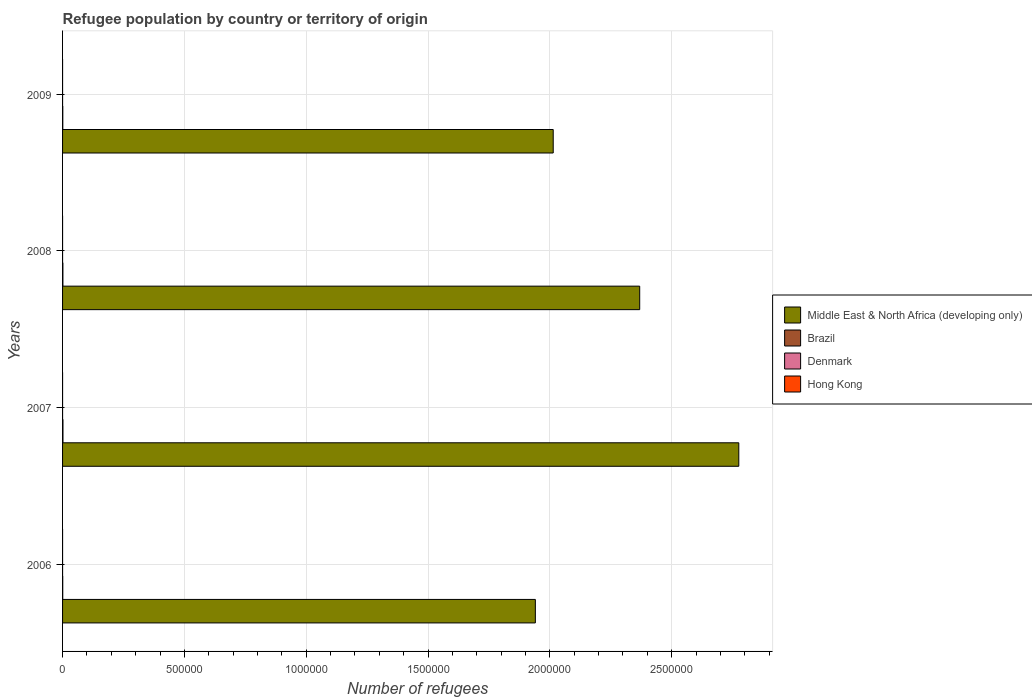How many different coloured bars are there?
Your response must be concise. 4. Are the number of bars on each tick of the Y-axis equal?
Make the answer very short. Yes. How many bars are there on the 3rd tick from the top?
Provide a succinct answer. 4. How many bars are there on the 4th tick from the bottom?
Offer a very short reply. 4. What is the label of the 2nd group of bars from the top?
Keep it short and to the point. 2008. In how many cases, is the number of bars for a given year not equal to the number of legend labels?
Your answer should be very brief. 0. What is the number of refugees in Brazil in 2006?
Provide a succinct answer. 707. Across all years, what is the maximum number of refugees in Brazil?
Your response must be concise. 1624. Across all years, what is the minimum number of refugees in Brazil?
Your answer should be compact. 707. In which year was the number of refugees in Hong Kong maximum?
Your response must be concise. 2009. In which year was the number of refugees in Hong Kong minimum?
Your answer should be very brief. 2006. What is the total number of refugees in Denmark in the graph?
Provide a succinct answer. 47. What is the difference between the number of refugees in Denmark in 2006 and that in 2008?
Offer a very short reply. 1. What is the difference between the number of refugees in Hong Kong in 2009 and the number of refugees in Denmark in 2008?
Your response must be concise. 1. What is the average number of refugees in Hong Kong per year?
Give a very brief answer. 11. In the year 2006, what is the difference between the number of refugees in Brazil and number of refugees in Middle East & North Africa (developing only)?
Provide a succinct answer. -1.94e+06. In how many years, is the number of refugees in Brazil greater than 700000 ?
Give a very brief answer. 0. What is the ratio of the number of refugees in Hong Kong in 2006 to that in 2008?
Keep it short and to the point. 0.91. Is the number of refugees in Hong Kong in 2006 less than that in 2009?
Your response must be concise. Yes. What is the difference between the highest and the second highest number of refugees in Brazil?
Make the answer very short. 220. What is the difference between the highest and the lowest number of refugees in Middle East & North Africa (developing only)?
Your answer should be very brief. 8.35e+05. Is the sum of the number of refugees in Hong Kong in 2007 and 2009 greater than the maximum number of refugees in Brazil across all years?
Give a very brief answer. No. Is it the case that in every year, the sum of the number of refugees in Denmark and number of refugees in Hong Kong is greater than the sum of number of refugees in Middle East & North Africa (developing only) and number of refugees in Brazil?
Provide a succinct answer. No. What does the 1st bar from the top in 2007 represents?
Offer a very short reply. Hong Kong. What does the 4th bar from the bottom in 2006 represents?
Make the answer very short. Hong Kong. Is it the case that in every year, the sum of the number of refugees in Hong Kong and number of refugees in Brazil is greater than the number of refugees in Middle East & North Africa (developing only)?
Your answer should be very brief. No. How many bars are there?
Your answer should be compact. 16. Are all the bars in the graph horizontal?
Provide a succinct answer. Yes. What is the difference between two consecutive major ticks on the X-axis?
Make the answer very short. 5.00e+05. Are the values on the major ticks of X-axis written in scientific E-notation?
Ensure brevity in your answer.  No. Does the graph contain any zero values?
Your answer should be compact. No. Where does the legend appear in the graph?
Keep it short and to the point. Center right. How many legend labels are there?
Keep it short and to the point. 4. How are the legend labels stacked?
Offer a terse response. Vertical. What is the title of the graph?
Provide a short and direct response. Refugee population by country or territory of origin. What is the label or title of the X-axis?
Provide a succinct answer. Number of refugees. What is the Number of refugees in Middle East & North Africa (developing only) in 2006?
Your answer should be compact. 1.94e+06. What is the Number of refugees in Brazil in 2006?
Your response must be concise. 707. What is the Number of refugees of Denmark in 2006?
Your answer should be very brief. 12. What is the Number of refugees in Hong Kong in 2006?
Keep it short and to the point. 10. What is the Number of refugees in Middle East & North Africa (developing only) in 2007?
Keep it short and to the point. 2.78e+06. What is the Number of refugees in Brazil in 2007?
Offer a terse response. 1624. What is the Number of refugees of Denmark in 2007?
Your answer should be compact. 14. What is the Number of refugees of Middle East & North Africa (developing only) in 2008?
Give a very brief answer. 2.37e+06. What is the Number of refugees in Brazil in 2008?
Give a very brief answer. 1404. What is the Number of refugees in Middle East & North Africa (developing only) in 2009?
Provide a succinct answer. 2.01e+06. What is the Number of refugees in Brazil in 2009?
Give a very brief answer. 973. What is the Number of refugees of Hong Kong in 2009?
Keep it short and to the point. 12. Across all years, what is the maximum Number of refugees of Middle East & North Africa (developing only)?
Your answer should be very brief. 2.78e+06. Across all years, what is the maximum Number of refugees in Brazil?
Your answer should be compact. 1624. Across all years, what is the maximum Number of refugees of Denmark?
Provide a short and direct response. 14. Across all years, what is the minimum Number of refugees of Middle East & North Africa (developing only)?
Make the answer very short. 1.94e+06. Across all years, what is the minimum Number of refugees of Brazil?
Ensure brevity in your answer.  707. What is the total Number of refugees in Middle East & North Africa (developing only) in the graph?
Your response must be concise. 9.10e+06. What is the total Number of refugees in Brazil in the graph?
Provide a short and direct response. 4708. What is the difference between the Number of refugees in Middle East & North Africa (developing only) in 2006 and that in 2007?
Provide a succinct answer. -8.35e+05. What is the difference between the Number of refugees of Brazil in 2006 and that in 2007?
Make the answer very short. -917. What is the difference between the Number of refugees of Middle East & North Africa (developing only) in 2006 and that in 2008?
Your answer should be compact. -4.28e+05. What is the difference between the Number of refugees of Brazil in 2006 and that in 2008?
Offer a very short reply. -697. What is the difference between the Number of refugees of Denmark in 2006 and that in 2008?
Your answer should be compact. 1. What is the difference between the Number of refugees in Hong Kong in 2006 and that in 2008?
Provide a succinct answer. -1. What is the difference between the Number of refugees in Middle East & North Africa (developing only) in 2006 and that in 2009?
Keep it short and to the point. -7.33e+04. What is the difference between the Number of refugees of Brazil in 2006 and that in 2009?
Your answer should be very brief. -266. What is the difference between the Number of refugees of Middle East & North Africa (developing only) in 2007 and that in 2008?
Your answer should be compact. 4.07e+05. What is the difference between the Number of refugees in Brazil in 2007 and that in 2008?
Offer a terse response. 220. What is the difference between the Number of refugees of Hong Kong in 2007 and that in 2008?
Provide a succinct answer. 0. What is the difference between the Number of refugees of Middle East & North Africa (developing only) in 2007 and that in 2009?
Offer a terse response. 7.62e+05. What is the difference between the Number of refugees in Brazil in 2007 and that in 2009?
Your answer should be compact. 651. What is the difference between the Number of refugees in Denmark in 2007 and that in 2009?
Your response must be concise. 4. What is the difference between the Number of refugees in Middle East & North Africa (developing only) in 2008 and that in 2009?
Give a very brief answer. 3.55e+05. What is the difference between the Number of refugees in Brazil in 2008 and that in 2009?
Keep it short and to the point. 431. What is the difference between the Number of refugees in Denmark in 2008 and that in 2009?
Your response must be concise. 1. What is the difference between the Number of refugees in Hong Kong in 2008 and that in 2009?
Provide a short and direct response. -1. What is the difference between the Number of refugees of Middle East & North Africa (developing only) in 2006 and the Number of refugees of Brazil in 2007?
Ensure brevity in your answer.  1.94e+06. What is the difference between the Number of refugees of Middle East & North Africa (developing only) in 2006 and the Number of refugees of Denmark in 2007?
Give a very brief answer. 1.94e+06. What is the difference between the Number of refugees of Middle East & North Africa (developing only) in 2006 and the Number of refugees of Hong Kong in 2007?
Give a very brief answer. 1.94e+06. What is the difference between the Number of refugees of Brazil in 2006 and the Number of refugees of Denmark in 2007?
Your answer should be compact. 693. What is the difference between the Number of refugees in Brazil in 2006 and the Number of refugees in Hong Kong in 2007?
Your answer should be very brief. 696. What is the difference between the Number of refugees of Denmark in 2006 and the Number of refugees of Hong Kong in 2007?
Your answer should be very brief. 1. What is the difference between the Number of refugees of Middle East & North Africa (developing only) in 2006 and the Number of refugees of Brazil in 2008?
Your answer should be compact. 1.94e+06. What is the difference between the Number of refugees of Middle East & North Africa (developing only) in 2006 and the Number of refugees of Denmark in 2008?
Your response must be concise. 1.94e+06. What is the difference between the Number of refugees of Middle East & North Africa (developing only) in 2006 and the Number of refugees of Hong Kong in 2008?
Provide a succinct answer. 1.94e+06. What is the difference between the Number of refugees of Brazil in 2006 and the Number of refugees of Denmark in 2008?
Your response must be concise. 696. What is the difference between the Number of refugees of Brazil in 2006 and the Number of refugees of Hong Kong in 2008?
Make the answer very short. 696. What is the difference between the Number of refugees of Middle East & North Africa (developing only) in 2006 and the Number of refugees of Brazil in 2009?
Offer a very short reply. 1.94e+06. What is the difference between the Number of refugees in Middle East & North Africa (developing only) in 2006 and the Number of refugees in Denmark in 2009?
Your answer should be compact. 1.94e+06. What is the difference between the Number of refugees in Middle East & North Africa (developing only) in 2006 and the Number of refugees in Hong Kong in 2009?
Provide a succinct answer. 1.94e+06. What is the difference between the Number of refugees in Brazil in 2006 and the Number of refugees in Denmark in 2009?
Your response must be concise. 697. What is the difference between the Number of refugees in Brazil in 2006 and the Number of refugees in Hong Kong in 2009?
Make the answer very short. 695. What is the difference between the Number of refugees of Middle East & North Africa (developing only) in 2007 and the Number of refugees of Brazil in 2008?
Your answer should be compact. 2.77e+06. What is the difference between the Number of refugees of Middle East & North Africa (developing only) in 2007 and the Number of refugees of Denmark in 2008?
Give a very brief answer. 2.78e+06. What is the difference between the Number of refugees in Middle East & North Africa (developing only) in 2007 and the Number of refugees in Hong Kong in 2008?
Your answer should be very brief. 2.78e+06. What is the difference between the Number of refugees in Brazil in 2007 and the Number of refugees in Denmark in 2008?
Offer a terse response. 1613. What is the difference between the Number of refugees in Brazil in 2007 and the Number of refugees in Hong Kong in 2008?
Keep it short and to the point. 1613. What is the difference between the Number of refugees in Denmark in 2007 and the Number of refugees in Hong Kong in 2008?
Offer a terse response. 3. What is the difference between the Number of refugees in Middle East & North Africa (developing only) in 2007 and the Number of refugees in Brazil in 2009?
Provide a short and direct response. 2.77e+06. What is the difference between the Number of refugees in Middle East & North Africa (developing only) in 2007 and the Number of refugees in Denmark in 2009?
Keep it short and to the point. 2.78e+06. What is the difference between the Number of refugees in Middle East & North Africa (developing only) in 2007 and the Number of refugees in Hong Kong in 2009?
Provide a short and direct response. 2.78e+06. What is the difference between the Number of refugees of Brazil in 2007 and the Number of refugees of Denmark in 2009?
Your response must be concise. 1614. What is the difference between the Number of refugees of Brazil in 2007 and the Number of refugees of Hong Kong in 2009?
Your answer should be compact. 1612. What is the difference between the Number of refugees in Middle East & North Africa (developing only) in 2008 and the Number of refugees in Brazil in 2009?
Offer a terse response. 2.37e+06. What is the difference between the Number of refugees in Middle East & North Africa (developing only) in 2008 and the Number of refugees in Denmark in 2009?
Keep it short and to the point. 2.37e+06. What is the difference between the Number of refugees of Middle East & North Africa (developing only) in 2008 and the Number of refugees of Hong Kong in 2009?
Keep it short and to the point. 2.37e+06. What is the difference between the Number of refugees in Brazil in 2008 and the Number of refugees in Denmark in 2009?
Ensure brevity in your answer.  1394. What is the difference between the Number of refugees in Brazil in 2008 and the Number of refugees in Hong Kong in 2009?
Provide a succinct answer. 1392. What is the average Number of refugees of Middle East & North Africa (developing only) per year?
Your answer should be very brief. 2.27e+06. What is the average Number of refugees of Brazil per year?
Provide a succinct answer. 1177. What is the average Number of refugees of Denmark per year?
Your response must be concise. 11.75. What is the average Number of refugees of Hong Kong per year?
Your response must be concise. 11. In the year 2006, what is the difference between the Number of refugees of Middle East & North Africa (developing only) and Number of refugees of Brazil?
Make the answer very short. 1.94e+06. In the year 2006, what is the difference between the Number of refugees of Middle East & North Africa (developing only) and Number of refugees of Denmark?
Make the answer very short. 1.94e+06. In the year 2006, what is the difference between the Number of refugees of Middle East & North Africa (developing only) and Number of refugees of Hong Kong?
Keep it short and to the point. 1.94e+06. In the year 2006, what is the difference between the Number of refugees of Brazil and Number of refugees of Denmark?
Ensure brevity in your answer.  695. In the year 2006, what is the difference between the Number of refugees in Brazil and Number of refugees in Hong Kong?
Your answer should be very brief. 697. In the year 2007, what is the difference between the Number of refugees in Middle East & North Africa (developing only) and Number of refugees in Brazil?
Keep it short and to the point. 2.77e+06. In the year 2007, what is the difference between the Number of refugees in Middle East & North Africa (developing only) and Number of refugees in Denmark?
Offer a terse response. 2.78e+06. In the year 2007, what is the difference between the Number of refugees of Middle East & North Africa (developing only) and Number of refugees of Hong Kong?
Offer a terse response. 2.78e+06. In the year 2007, what is the difference between the Number of refugees in Brazil and Number of refugees in Denmark?
Offer a terse response. 1610. In the year 2007, what is the difference between the Number of refugees in Brazil and Number of refugees in Hong Kong?
Keep it short and to the point. 1613. In the year 2008, what is the difference between the Number of refugees in Middle East & North Africa (developing only) and Number of refugees in Brazil?
Offer a terse response. 2.37e+06. In the year 2008, what is the difference between the Number of refugees of Middle East & North Africa (developing only) and Number of refugees of Denmark?
Provide a succinct answer. 2.37e+06. In the year 2008, what is the difference between the Number of refugees of Middle East & North Africa (developing only) and Number of refugees of Hong Kong?
Give a very brief answer. 2.37e+06. In the year 2008, what is the difference between the Number of refugees of Brazil and Number of refugees of Denmark?
Give a very brief answer. 1393. In the year 2008, what is the difference between the Number of refugees in Brazil and Number of refugees in Hong Kong?
Your answer should be compact. 1393. In the year 2008, what is the difference between the Number of refugees in Denmark and Number of refugees in Hong Kong?
Offer a terse response. 0. In the year 2009, what is the difference between the Number of refugees of Middle East & North Africa (developing only) and Number of refugees of Brazil?
Your answer should be compact. 2.01e+06. In the year 2009, what is the difference between the Number of refugees of Middle East & North Africa (developing only) and Number of refugees of Denmark?
Your response must be concise. 2.01e+06. In the year 2009, what is the difference between the Number of refugees in Middle East & North Africa (developing only) and Number of refugees in Hong Kong?
Ensure brevity in your answer.  2.01e+06. In the year 2009, what is the difference between the Number of refugees in Brazil and Number of refugees in Denmark?
Your answer should be compact. 963. In the year 2009, what is the difference between the Number of refugees of Brazil and Number of refugees of Hong Kong?
Ensure brevity in your answer.  961. In the year 2009, what is the difference between the Number of refugees in Denmark and Number of refugees in Hong Kong?
Offer a terse response. -2. What is the ratio of the Number of refugees in Middle East & North Africa (developing only) in 2006 to that in 2007?
Offer a terse response. 0.7. What is the ratio of the Number of refugees of Brazil in 2006 to that in 2007?
Give a very brief answer. 0.44. What is the ratio of the Number of refugees in Denmark in 2006 to that in 2007?
Your response must be concise. 0.86. What is the ratio of the Number of refugees of Hong Kong in 2006 to that in 2007?
Keep it short and to the point. 0.91. What is the ratio of the Number of refugees of Middle East & North Africa (developing only) in 2006 to that in 2008?
Offer a terse response. 0.82. What is the ratio of the Number of refugees in Brazil in 2006 to that in 2008?
Offer a very short reply. 0.5. What is the ratio of the Number of refugees in Middle East & North Africa (developing only) in 2006 to that in 2009?
Your answer should be very brief. 0.96. What is the ratio of the Number of refugees of Brazil in 2006 to that in 2009?
Offer a very short reply. 0.73. What is the ratio of the Number of refugees of Hong Kong in 2006 to that in 2009?
Offer a terse response. 0.83. What is the ratio of the Number of refugees in Middle East & North Africa (developing only) in 2007 to that in 2008?
Keep it short and to the point. 1.17. What is the ratio of the Number of refugees in Brazil in 2007 to that in 2008?
Make the answer very short. 1.16. What is the ratio of the Number of refugees of Denmark in 2007 to that in 2008?
Make the answer very short. 1.27. What is the ratio of the Number of refugees in Middle East & North Africa (developing only) in 2007 to that in 2009?
Provide a succinct answer. 1.38. What is the ratio of the Number of refugees in Brazil in 2007 to that in 2009?
Keep it short and to the point. 1.67. What is the ratio of the Number of refugees in Middle East & North Africa (developing only) in 2008 to that in 2009?
Provide a succinct answer. 1.18. What is the ratio of the Number of refugees in Brazil in 2008 to that in 2009?
Ensure brevity in your answer.  1.44. What is the difference between the highest and the second highest Number of refugees in Middle East & North Africa (developing only)?
Give a very brief answer. 4.07e+05. What is the difference between the highest and the second highest Number of refugees of Brazil?
Give a very brief answer. 220. What is the difference between the highest and the second highest Number of refugees in Denmark?
Offer a terse response. 2. What is the difference between the highest and the lowest Number of refugees in Middle East & North Africa (developing only)?
Your answer should be compact. 8.35e+05. What is the difference between the highest and the lowest Number of refugees in Brazil?
Ensure brevity in your answer.  917. What is the difference between the highest and the lowest Number of refugees in Denmark?
Your answer should be very brief. 4. 